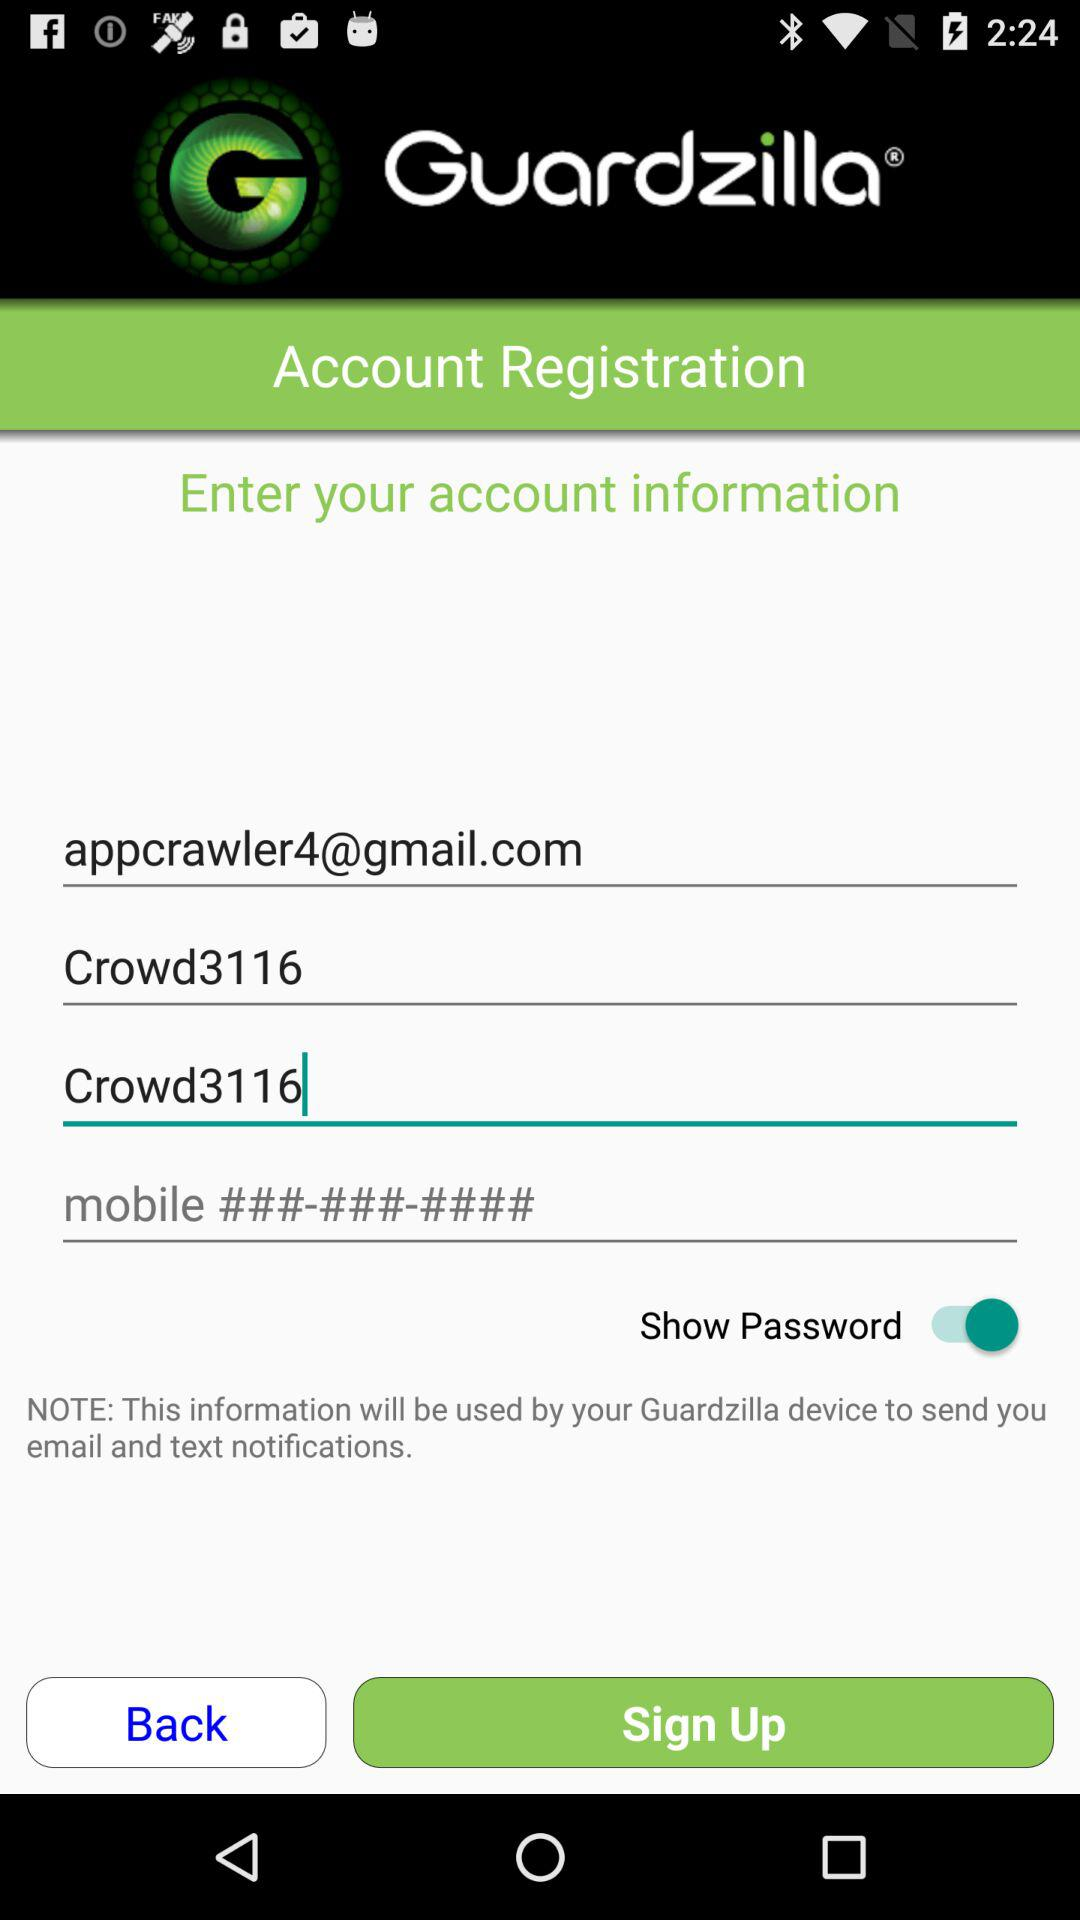What is the password?
Answer the question using a single word or phrase. The password is "Crowd3116." 